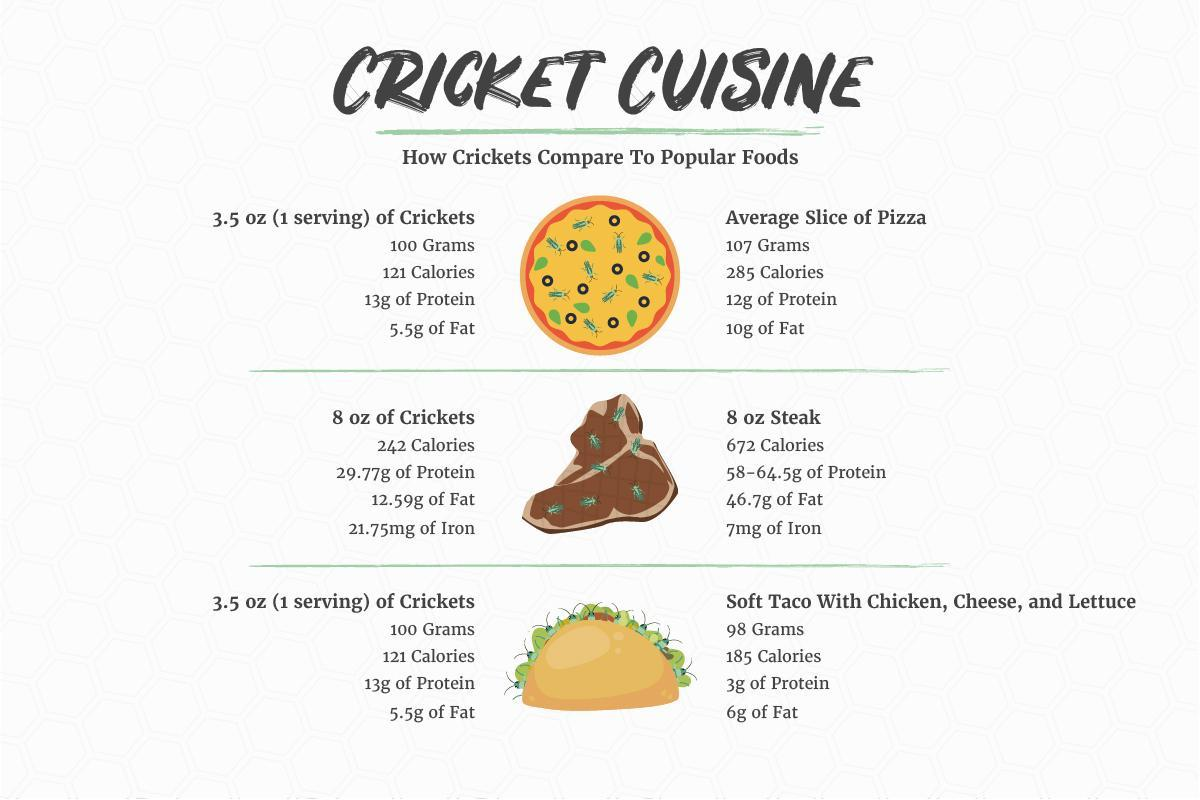How many calories 8 oz of crickets and steak constitutes?
Answer the question with a short phrase. 914 